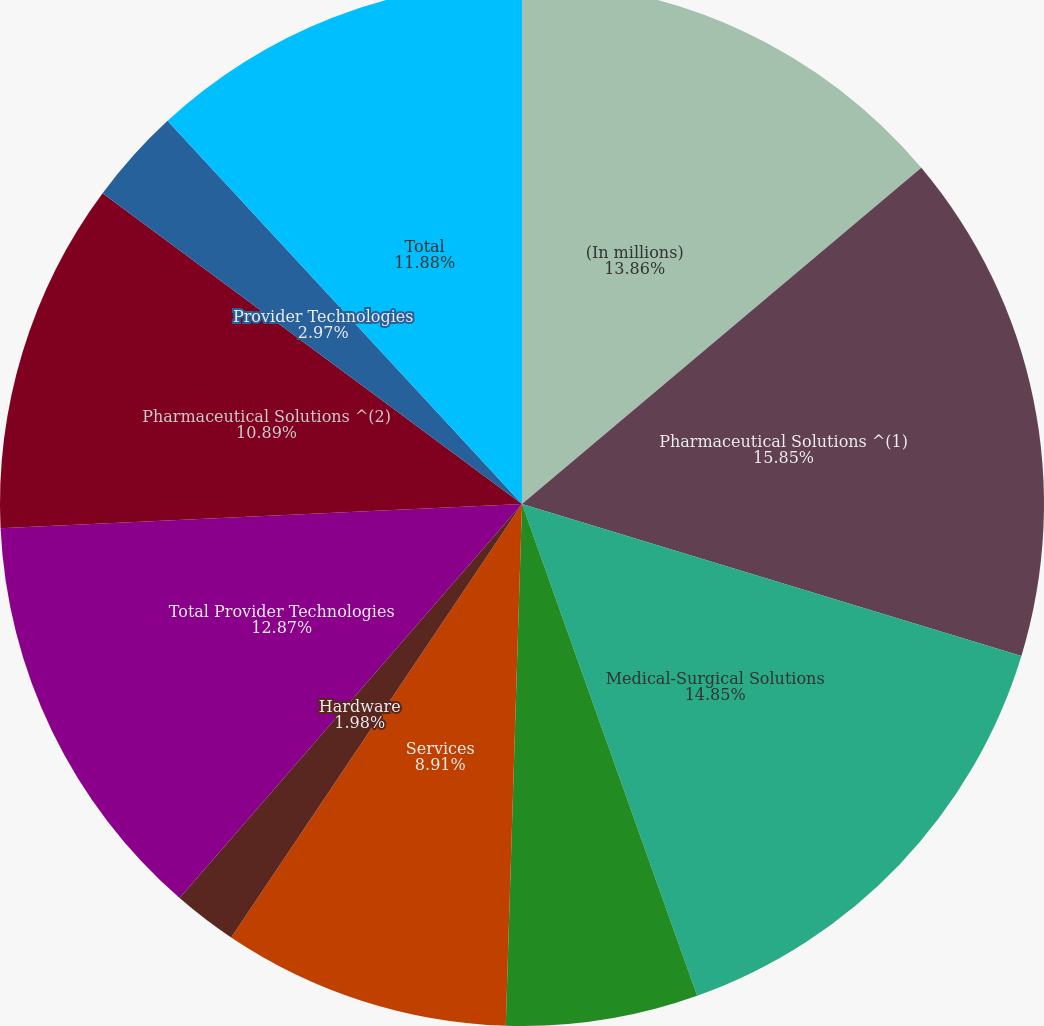Convert chart. <chart><loc_0><loc_0><loc_500><loc_500><pie_chart><fcel>(In millions)<fcel>Pharmaceutical Solutions ^(1)<fcel>Medical-Surgical Solutions<fcel>Software and software systems<fcel>Services<fcel>Hardware<fcel>Total Provider Technologies<fcel>Pharmaceutical Solutions ^(2)<fcel>Provider Technologies<fcel>Total<nl><fcel>13.86%<fcel>15.84%<fcel>14.85%<fcel>5.94%<fcel>8.91%<fcel>1.98%<fcel>12.87%<fcel>10.89%<fcel>2.97%<fcel>11.88%<nl></chart> 